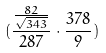Convert formula to latex. <formula><loc_0><loc_0><loc_500><loc_500>( \frac { \frac { 8 2 } { \sqrt { 3 4 3 } } } { 2 8 7 } \cdot \frac { 3 7 8 } { 9 } )</formula> 